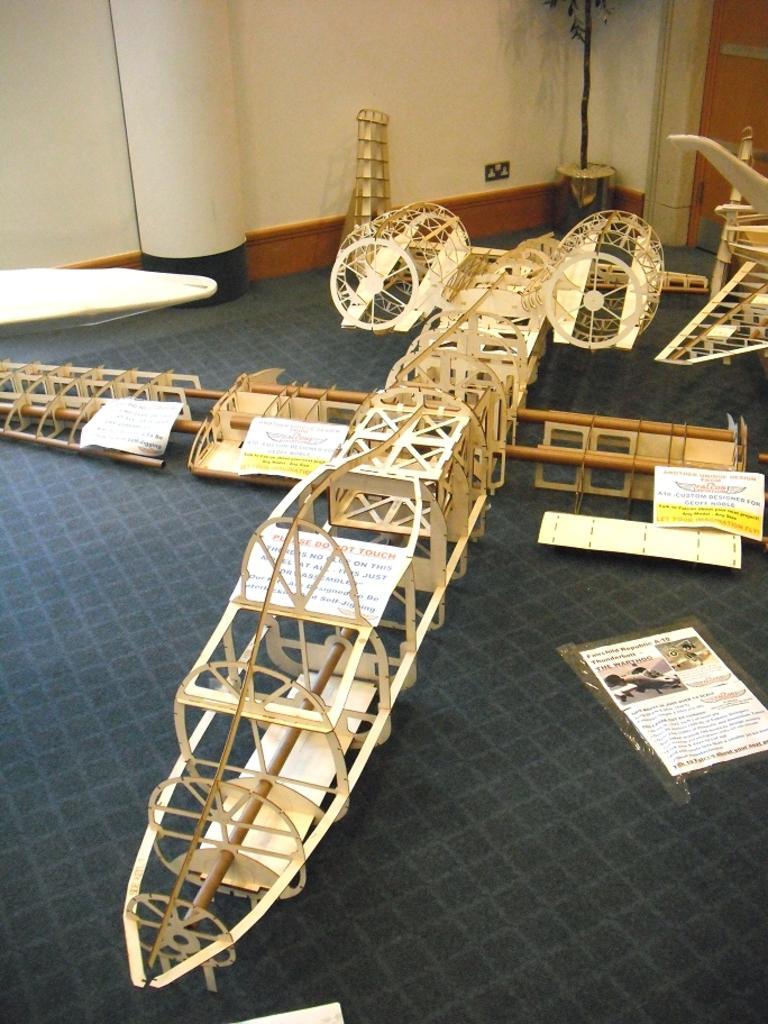Describe this image in one or two sentences. In this picture we can see a large scale model aircraft on the path. There are some papers on the path. We can see a houseplant in the corner. There is a door, wall and a pillar is visible in the background. 